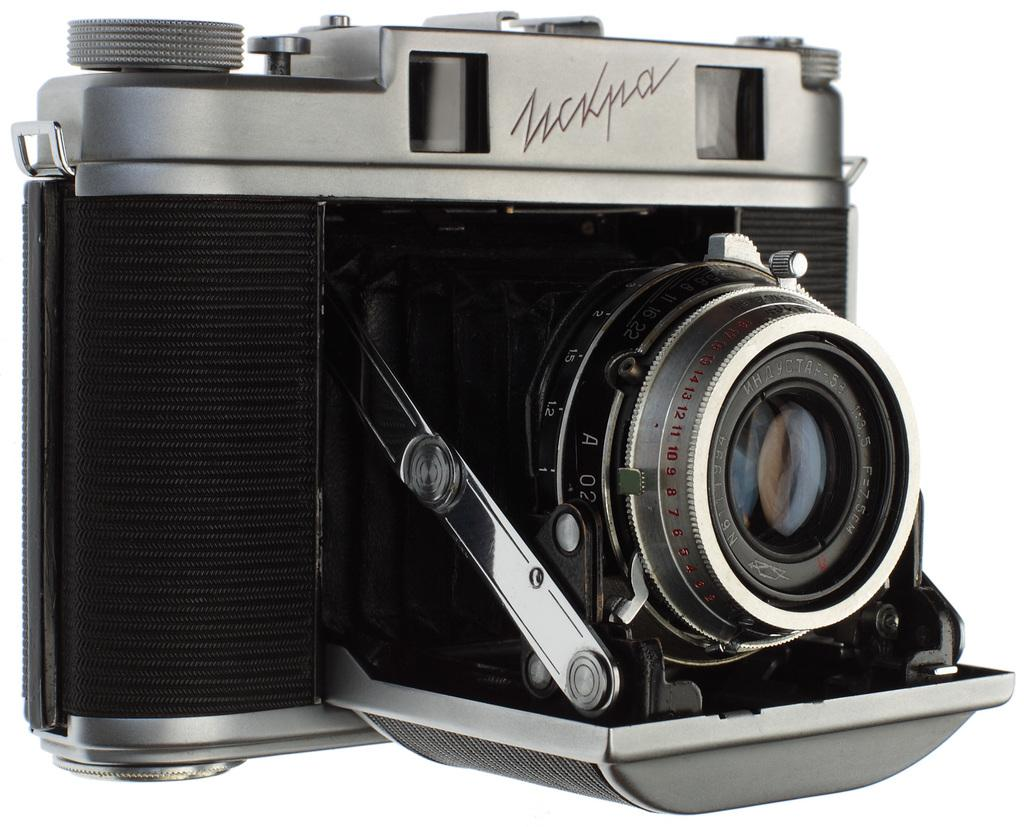What object is the main focus of the image? There is a camera in the image. Can you describe the camera in the image? The image only shows a camera, so it is not possible to provide a detailed description of it. What type of grain is being harvested in the image? There is no grain present in the image; it only features a camera. 